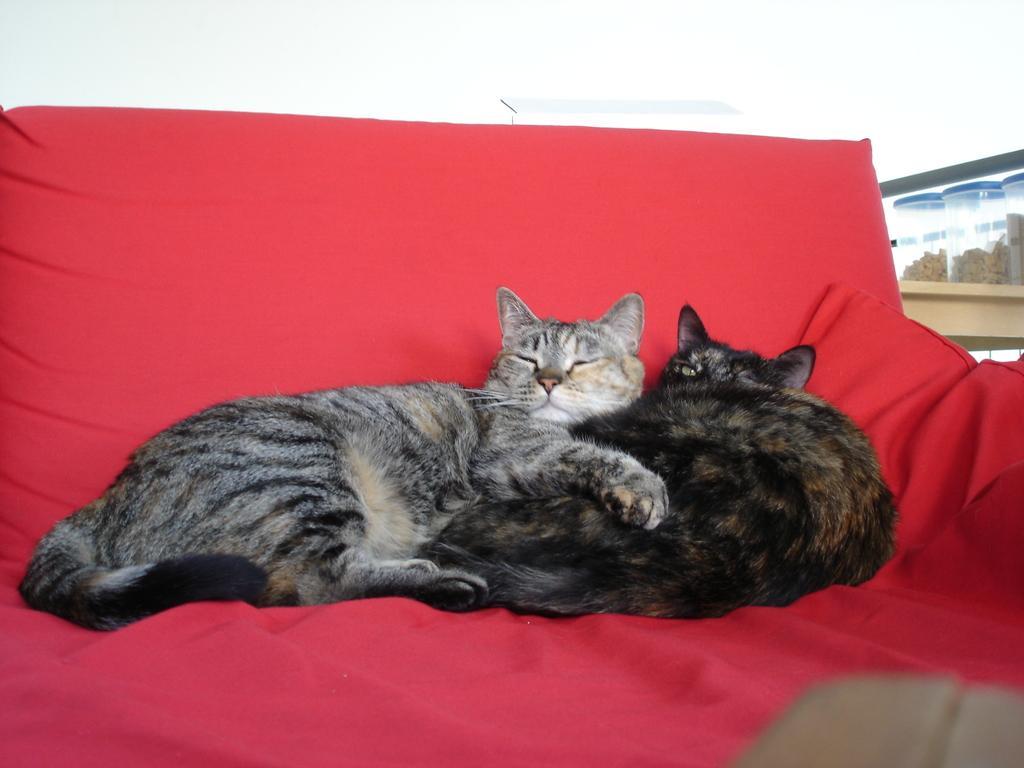In one or two sentences, can you explain what this image depicts? In this image I can see there are two cats sitting on bed and I can see red color cloth visible on the bed. 